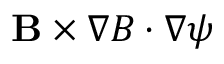<formula> <loc_0><loc_0><loc_500><loc_500>\mathbf B \times \nabla B \cdot \nabla \psi</formula> 